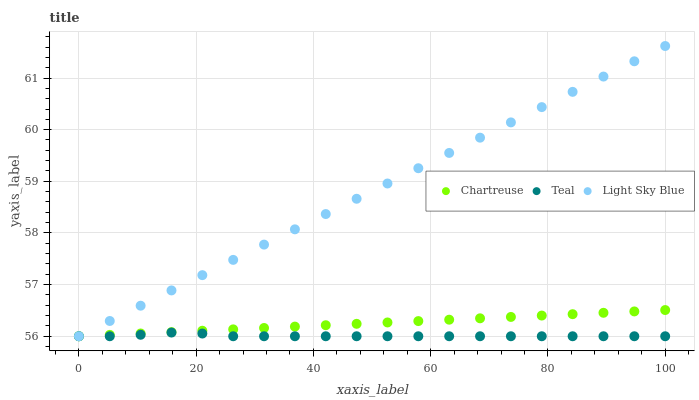Does Teal have the minimum area under the curve?
Answer yes or no. Yes. Does Light Sky Blue have the maximum area under the curve?
Answer yes or no. Yes. Does Light Sky Blue have the minimum area under the curve?
Answer yes or no. No. Does Teal have the maximum area under the curve?
Answer yes or no. No. Is Chartreuse the smoothest?
Answer yes or no. Yes. Is Teal the roughest?
Answer yes or no. Yes. Is Light Sky Blue the smoothest?
Answer yes or no. No. Is Light Sky Blue the roughest?
Answer yes or no. No. Does Chartreuse have the lowest value?
Answer yes or no. Yes. Does Light Sky Blue have the highest value?
Answer yes or no. Yes. Does Teal have the highest value?
Answer yes or no. No. Does Chartreuse intersect Light Sky Blue?
Answer yes or no. Yes. Is Chartreuse less than Light Sky Blue?
Answer yes or no. No. Is Chartreuse greater than Light Sky Blue?
Answer yes or no. No. 